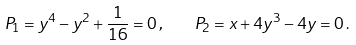Convert formula to latex. <formula><loc_0><loc_0><loc_500><loc_500>P _ { 1 } = y ^ { 4 } - y ^ { 2 } + \frac { 1 } { 1 6 } = 0 \, , \quad P _ { 2 } = x + 4 y ^ { 3 } - 4 y = 0 \, .</formula> 